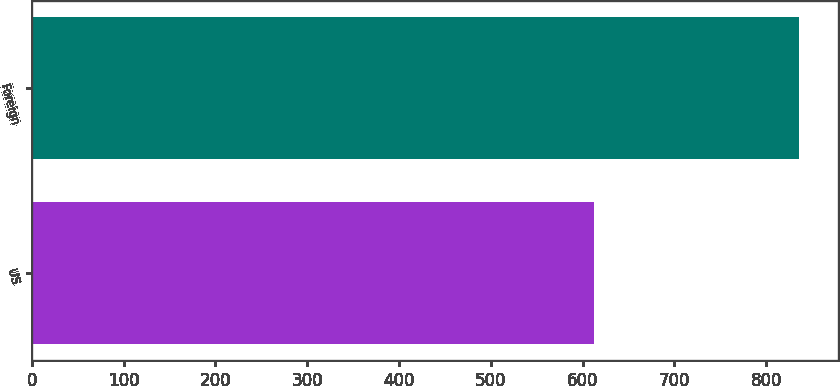Convert chart to OTSL. <chart><loc_0><loc_0><loc_500><loc_500><bar_chart><fcel>US<fcel>Foreign<nl><fcel>612<fcel>836<nl></chart> 